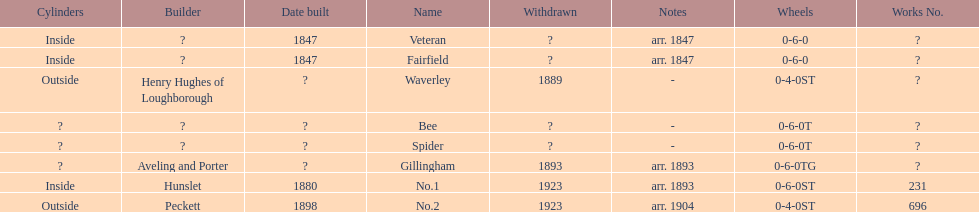Can you parse all the data within this table? {'header': ['Cylinders', 'Builder', 'Date built', 'Name', 'Withdrawn', 'Notes', 'Wheels', 'Works No.'], 'rows': [['Inside', '?', '1847', 'Veteran', '?', 'arr. 1847', '0-6-0', '?'], ['Inside', '?', '1847', 'Fairfield', '?', 'arr. 1847', '0-6-0', '?'], ['Outside', 'Henry Hughes of Loughborough', '?', 'Waverley', '1889', '-', '0-4-0ST', '?'], ['?', '?', '?', 'Bee', '?', '-', '0-6-0T', '?'], ['?', '?', '?', 'Spider', '?', '-', '0-6-0T', '?'], ['?', 'Aveling and Porter', '?', 'Gillingham', '1893', 'arr. 1893', '0-6-0TG', '?'], ['Inside', 'Hunslet', '1880', 'No.1', '1923', 'arr. 1893', '0-6-0ST', '231'], ['Outside', 'Peckett', '1898', 'No.2', '1923', 'arr. 1904', '0-4-0ST', '696']]} Were there more with inside or outside cylinders? Inside. 